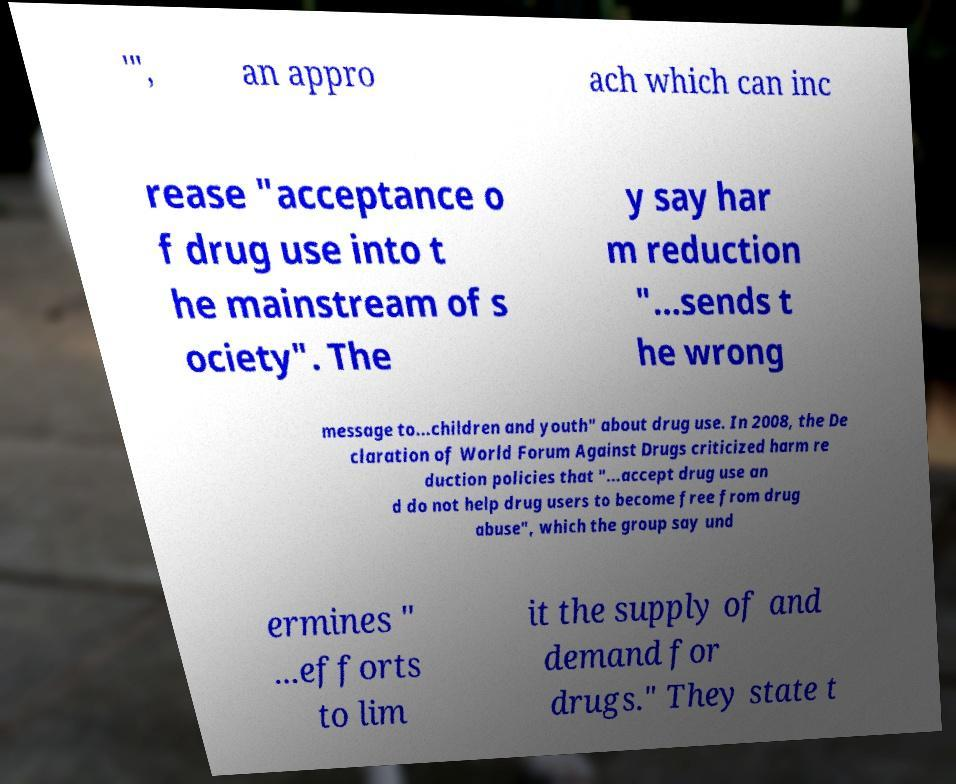What messages or text are displayed in this image? I need them in a readable, typed format. '", an appro ach which can inc rease "acceptance o f drug use into t he mainstream of s ociety". The y say har m reduction "...sends t he wrong message to...children and youth" about drug use. In 2008, the De claration of World Forum Against Drugs criticized harm re duction policies that "...accept drug use an d do not help drug users to become free from drug abuse", which the group say und ermines " ...efforts to lim it the supply of and demand for drugs." They state t 